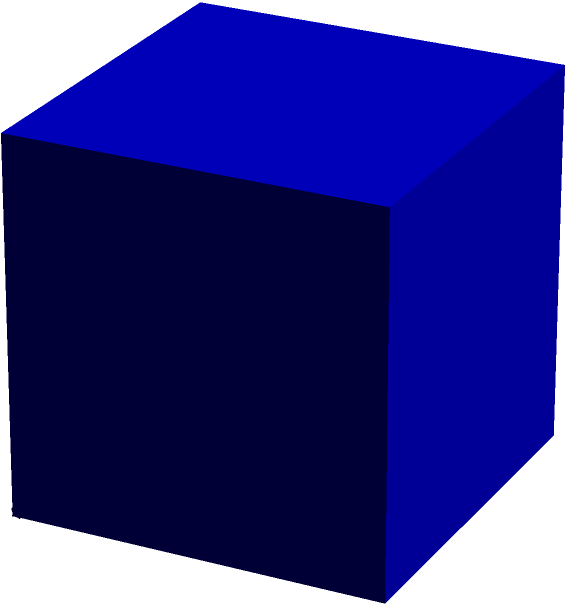As a project manager overseeing D language development, you need to optimize a data structure for storing cube dimensions. If the edge length of a cube is represented by $a$, express the surface area of the cube in terms of $a$. How would you implement this calculation efficiently in D? To calculate the surface area of a cube and implement it efficiently in D, follow these steps:

1. Understand the formula:
   - A cube has 6 identical square faces
   - Each face has an area of $a^2$
   - Total surface area = $6 * a^2$

2. Implement in D:
   ```d
   double calculateCubeSurfaceArea(double a) {
       return 6 * (a * a);
   }
   ```

3. Optimization considerations:
   - Use `a * a` instead of `pow(a, 2)` for better performance
   - Consider using `@nogc` attribute for memory-efficient code
   - For frequent calculations, implement a lookup table or memoization

4. Final formula: Surface Area = $6a^2$

This implementation is both mathematically correct and optimized for performance in D.
Answer: $6a^2$ 